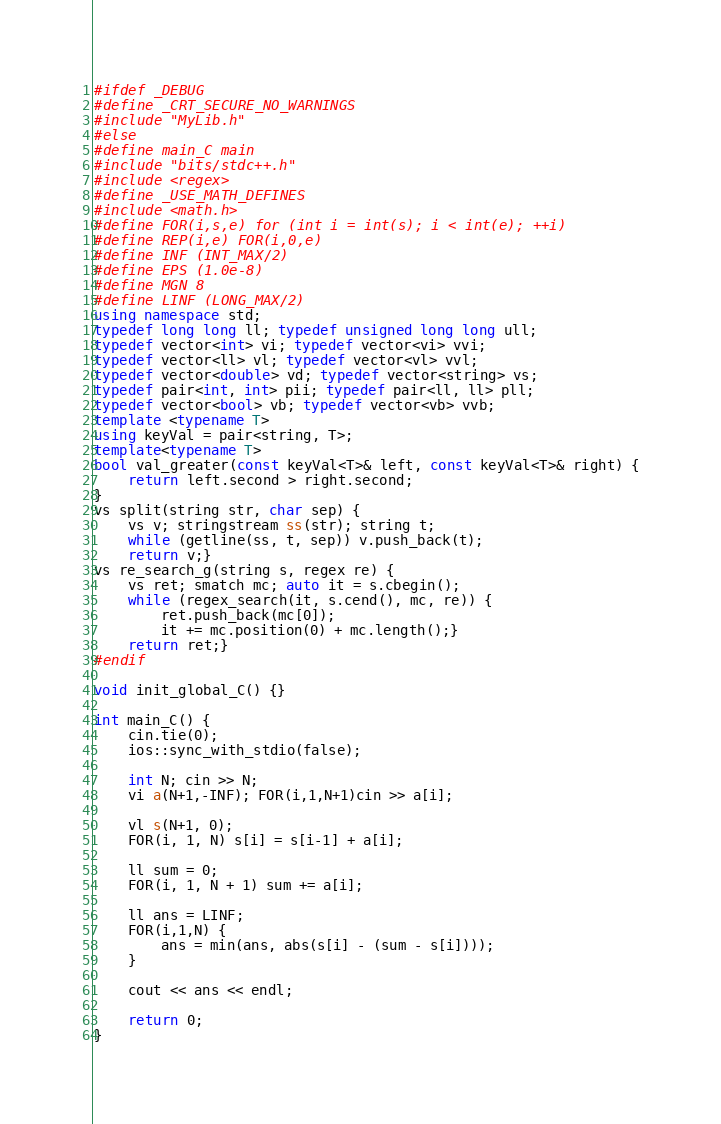<code> <loc_0><loc_0><loc_500><loc_500><_C++_>#ifdef _DEBUG
#define _CRT_SECURE_NO_WARNINGS
#include "MyLib.h"
#else
#define main_C main
#include "bits/stdc++.h" 
#include <regex>
#define _USE_MATH_DEFINES
#include <math.h>
#define FOR(i,s,e) for (int i = int(s); i < int(e); ++i)
#define REP(i,e) FOR(i,0,e)
#define INF (INT_MAX/2)
#define EPS (1.0e-8)
#define MGN 8
#define LINF (LONG_MAX/2)
using namespace std;
typedef long long ll; typedef unsigned long long ull;
typedef vector<int> vi; typedef vector<vi> vvi;
typedef vector<ll> vl; typedef vector<vl> vvl;
typedef vector<double> vd; typedef vector<string> vs;
typedef pair<int, int> pii; typedef pair<ll, ll> pll;
typedef vector<bool> vb; typedef vector<vb> vvb;
template <typename T>
using keyVal = pair<string, T>;
template<typename T>
bool val_greater(const keyVal<T>& left, const keyVal<T>& right) {
    return left.second > right.second;
}
vs split(string str, char sep) {
    vs v; stringstream ss(str); string t;
    while (getline(ss, t, sep)) v.push_back(t);
    return v;}
vs re_search_g(string s, regex re) {
    vs ret; smatch mc; auto it = s.cbegin();
    while (regex_search(it, s.cend(), mc, re)) {
        ret.push_back(mc[0]);
        it += mc.position(0) + mc.length();}
    return ret;}
#endif

void init_global_C() {}

int main_C() {
    cin.tie(0);
    ios::sync_with_stdio(false);
    
    int N; cin >> N;
    vi a(N+1,-INF); FOR(i,1,N+1)cin >> a[i];
    
    vl s(N+1, 0);
    FOR(i, 1, N) s[i] = s[i-1] + a[i];

    ll sum = 0;
    FOR(i, 1, N + 1) sum += a[i];

    ll ans = LINF;
    FOR(i,1,N) {
        ans = min(ans, abs(s[i] - (sum - s[i])));
    }

    cout << ans << endl;

    return 0;
}</code> 